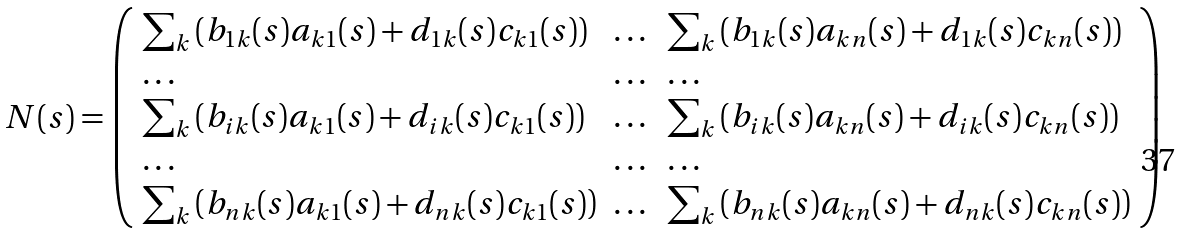Convert formula to latex. <formula><loc_0><loc_0><loc_500><loc_500>N ( s ) = \left ( \begin{array} { l l l } \sum _ { k } \left ( b _ { 1 k } ( s ) a _ { k 1 } ( s ) + d _ { 1 k } ( s ) c _ { k 1 } ( s ) \right ) & \dots & \sum _ { k } \left ( b _ { 1 k } ( s ) a _ { k n } ( s ) + d _ { 1 k } ( s ) c _ { k n } ( s ) \right ) \\ \dots & \dots & \dots \\ \sum _ { k } \left ( b _ { i k } ( s ) a _ { k 1 } ( s ) + d _ { i k } ( s ) c _ { k 1 } ( s ) \right ) & \dots & \sum _ { k } \left ( b _ { i k } ( s ) a _ { k n } ( s ) + d _ { i k } ( s ) c _ { k n } ( s ) \right ) \\ \dots & \dots & \dots \\ \sum _ { k } \left ( b _ { n k } ( s ) a _ { k 1 } ( s ) + d _ { n k } ( s ) c _ { k 1 } ( s ) \right ) & \dots & \sum _ { k } \left ( b _ { n k } ( s ) a _ { k n } ( s ) + d _ { n k } ( s ) c _ { k n } ( s ) \right ) \end{array} \right )</formula> 